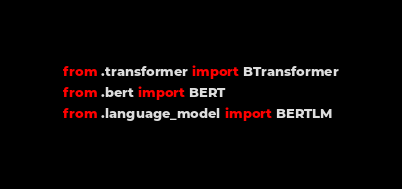Convert code to text. <code><loc_0><loc_0><loc_500><loc_500><_Python_>from .transformer import BTransformer
from .bert import BERT
from .language_model import BERTLM
</code> 